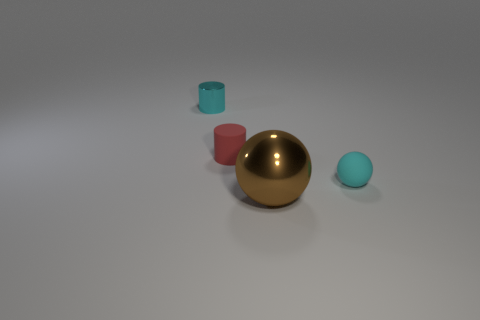Subtract 0 green spheres. How many objects are left? 4 Subtract 1 balls. How many balls are left? 1 Subtract all cyan cylinders. Subtract all green spheres. How many cylinders are left? 1 Subtract all yellow cylinders. How many cyan balls are left? 1 Subtract all small yellow metal things. Subtract all cyan metallic objects. How many objects are left? 3 Add 3 cyan things. How many cyan things are left? 5 Add 1 small red things. How many small red things exist? 2 Add 4 large spheres. How many objects exist? 8 